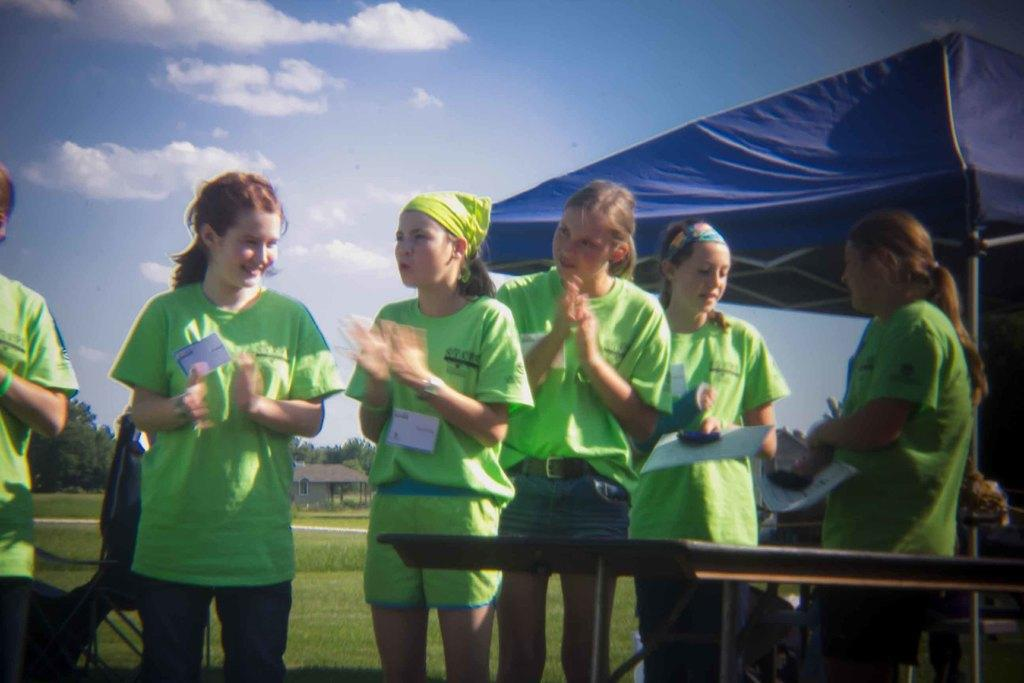Who or what can be seen in the image? There are people in the image. What is the ground covered with? The ground is covered with grass. What type of barrier is present in the image? There is fencing in the image. What type of structure can be seen in the image? There is a shed in the image. What type of building is visible in the image? There is a house in the image. What part of the natural environment is visible in the image? The sky is visible in the image. What can be observed in the sky? There are clouds in the sky. What type of sweater is the business wearing in the image? There is no business or sweater present in the image. 